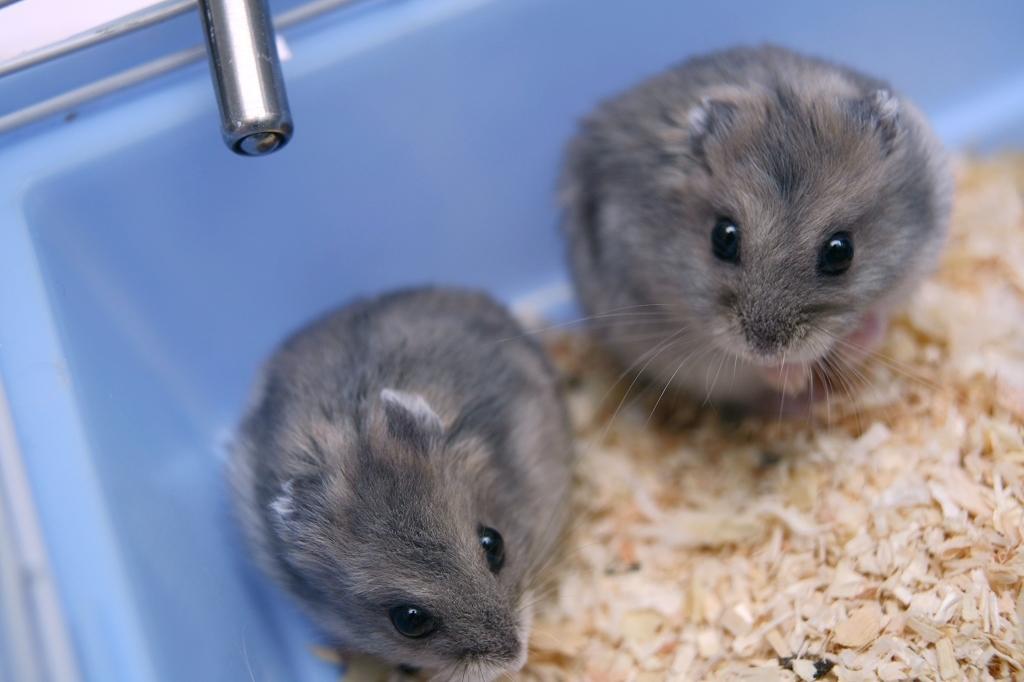Could you give a brief overview of what you see in this image? This picture consists of two mice in the center of the image in a tub and there is metal object at the top side of the image, it seems to be there is chopped wood in the image. 